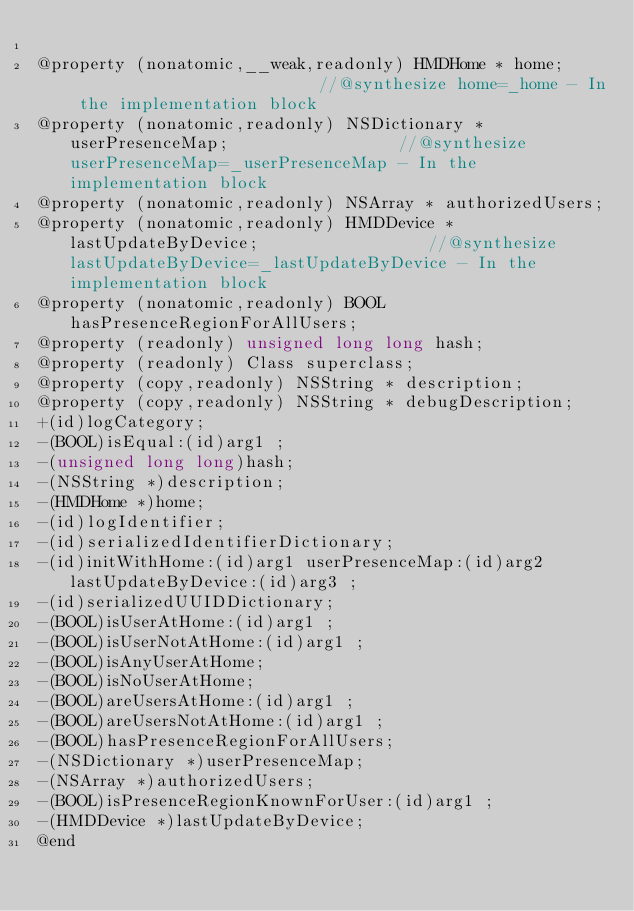Convert code to text. <code><loc_0><loc_0><loc_500><loc_500><_C_>
@property (nonatomic,__weak,readonly) HMDHome * home;                          //@synthesize home=_home - In the implementation block
@property (nonatomic,readonly) NSDictionary * userPresenceMap;                 //@synthesize userPresenceMap=_userPresenceMap - In the implementation block
@property (nonatomic,readonly) NSArray * authorizedUsers; 
@property (nonatomic,readonly) HMDDevice * lastUpdateByDevice;                 //@synthesize lastUpdateByDevice=_lastUpdateByDevice - In the implementation block
@property (nonatomic,readonly) BOOL hasPresenceRegionForAllUsers; 
@property (readonly) unsigned long long hash; 
@property (readonly) Class superclass; 
@property (copy,readonly) NSString * description; 
@property (copy,readonly) NSString * debugDescription; 
+(id)logCategory;
-(BOOL)isEqual:(id)arg1 ;
-(unsigned long long)hash;
-(NSString *)description;
-(HMDHome *)home;
-(id)logIdentifier;
-(id)serializedIdentifierDictionary;
-(id)initWithHome:(id)arg1 userPresenceMap:(id)arg2 lastUpdateByDevice:(id)arg3 ;
-(id)serializedUUIDDictionary;
-(BOOL)isUserAtHome:(id)arg1 ;
-(BOOL)isUserNotAtHome:(id)arg1 ;
-(BOOL)isAnyUserAtHome;
-(BOOL)isNoUserAtHome;
-(BOOL)areUsersAtHome:(id)arg1 ;
-(BOOL)areUsersNotAtHome:(id)arg1 ;
-(BOOL)hasPresenceRegionForAllUsers;
-(NSDictionary *)userPresenceMap;
-(NSArray *)authorizedUsers;
-(BOOL)isPresenceRegionKnownForUser:(id)arg1 ;
-(HMDDevice *)lastUpdateByDevice;
@end

</code> 